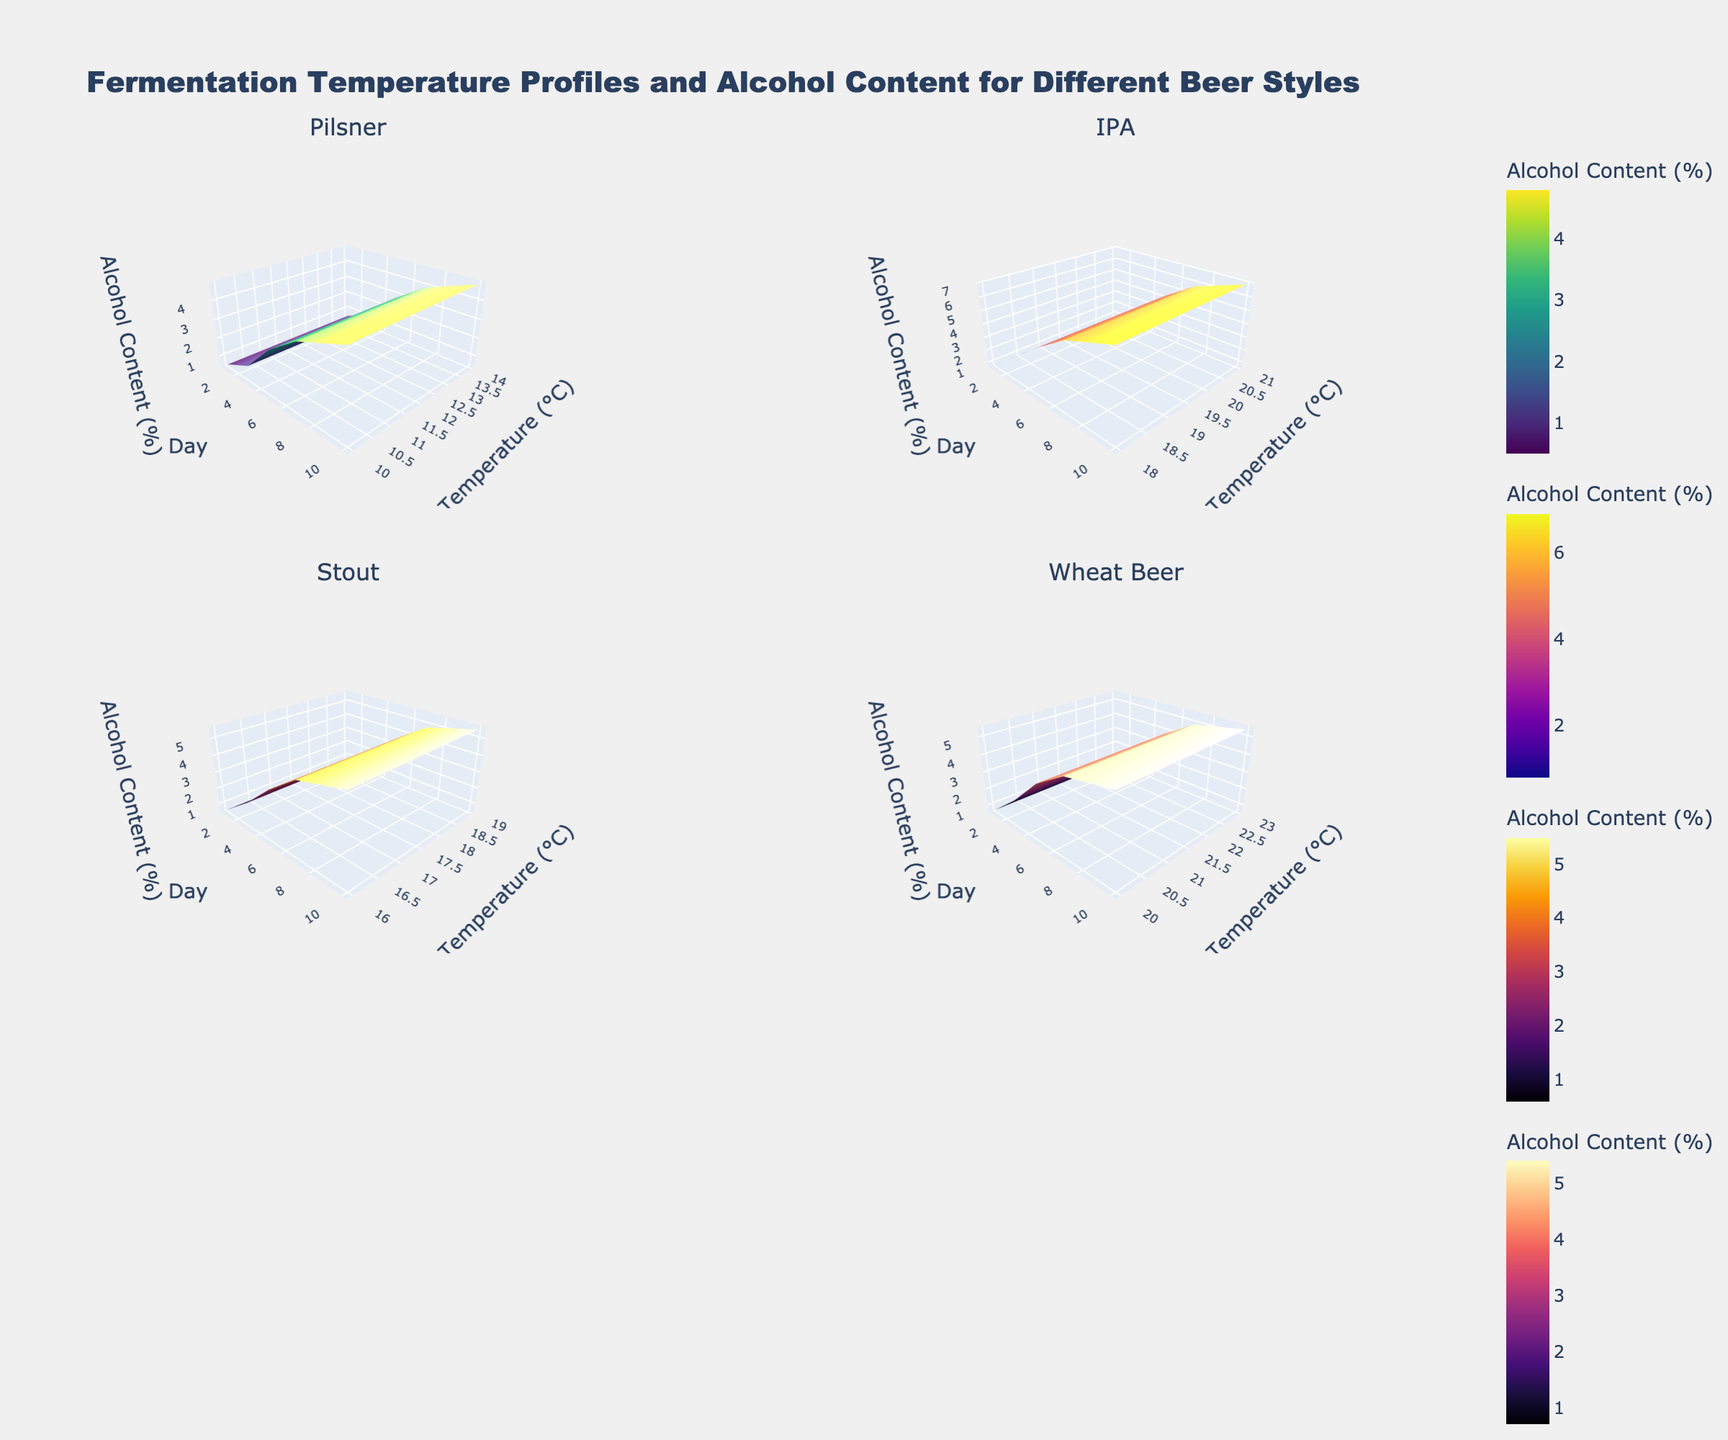How many beer styles are shown in the figure? The subplot titles indicate the different beer styles. There are four subplot titles visible in the figure.
Answer: Four Which beer style has the highest initial fermentation temperature? By comparing the start temperatures (Day 1) for each style on the y-axis, we see that Wheat Beer starts at 20°C, which is higher than the others.
Answer: Wheat Beer Which style shows the greatest variation in fermentation temperature? By comparing the range of temperatures for each beer style across all days, IPA shows variation from 18°C to 21°C, a 3°C range, whereas others have smaller ranges.
Answer: IPA Which style reaches the highest alcohol content by Day 10? By observing the z-coordinate (Alcohol Content) for Day 10, IPA reaches about 6.9%, which is higher than any other style.
Answer: IPA How does the temperature trend of Pilsner compare to that of Stout over the days? Pilsner's temperature tends to increase and then decrease, while Stout's temperature increases and then slightly drops. Both start with a rise, but Pilsner decreases more significantly after Day 7.
Answer: Pilsner increases then decreases more significantly What is the relationship between temperature and alcohol content for Wheat Beer? Wheat Beer shows a general trend: as temperature increases from 20°C to 23°C by Day 5, alcohol content also increases, then both temperature and alcohol content decrease after Day 7.
Answer: Alcohol content increases with temperature initially, then both decrease Which beer style shows the most consistent alcohol content increase over time? By comparing the smoothness and slope of the alcohol content lines for each style, Wheat Beer shows a steady and consistent increase compared to others.
Answer: Wheat Beer What is the approximate average temperature on Day 5 across all beer styles? According to the plot, the temperatures on Day 5 are around 13°C (Pilsner), 21°C (IPA), 19°C (Stout), and 23°C (Wheat Beer). The average = (13 + 21 + 19 + 23) / 4. The mathematical steps are: 76 / 4 = 19.
Answer: 19°C Does IPA show a decrease in temperature at any point during the fermentation process? By looking at the temperature trend for IPA, we see a decrease from 21°C on Day 5 to 19°C on Day 7.
Answer: Yes Which beer style has a temperature peak that's not at Day 1 or Day 10? By scanning the temperature trends, Stout peaks at 19°C on Day 5, differentiating from Day 1 or 10.
Answer: Stout 